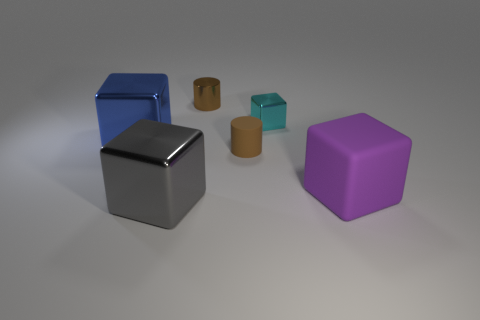What shape is the gray object? The gray object is a perfect example of a cube. A cube is a three-dimensional shape with six square faces of equal size, twelve straight edges, and eight vertices. The uniformity and symmetry of its structure are what defines it as a cube. 